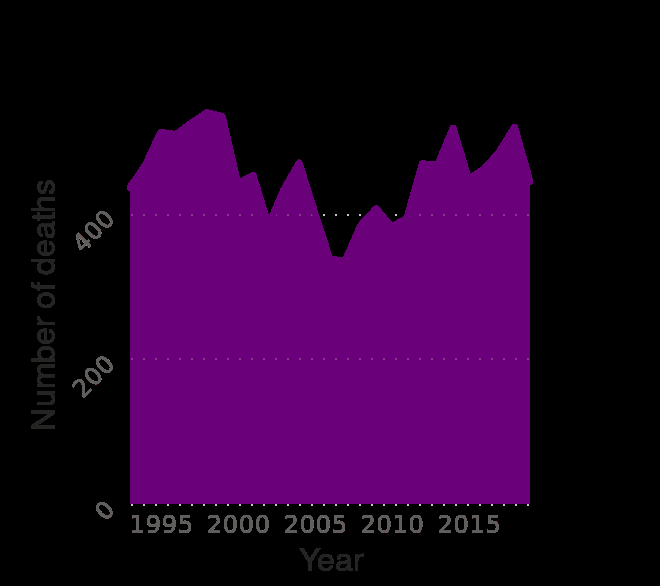<image>
Can you provide the exact number of deaths in any specific year from the figure? No, the figure does not provide specific numbers for deaths in any particular year. please summary the statistics and relations of the chart The number of deaths has been anywhere between about 320 to 550 a year. The lowest amount of deaths seems to be sometime between 2005 and 2010, with the lowest point likely being somewhere around 2007. It is a graph with many peaks and it's hard to discern to which years exactly those peaks fall to. What can be said about the pattern of deaths over the years? The pattern of deaths shows a graph with many peaks and it is hard to determine the specific years where those peaks occur. Does the figure provide specific numbers for deaths in any particular year? No.No, the figure does not provide specific numbers for deaths in any particular year. 